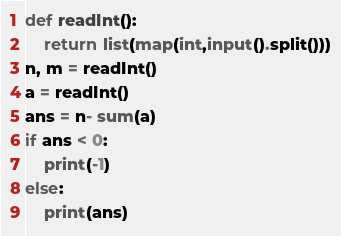<code> <loc_0><loc_0><loc_500><loc_500><_Python_>def readInt():
    return list(map(int,input().split()))
n, m = readInt()
a = readInt()
ans = n- sum(a)
if ans < 0:
    print(-1)
else:
    print(ans)</code> 